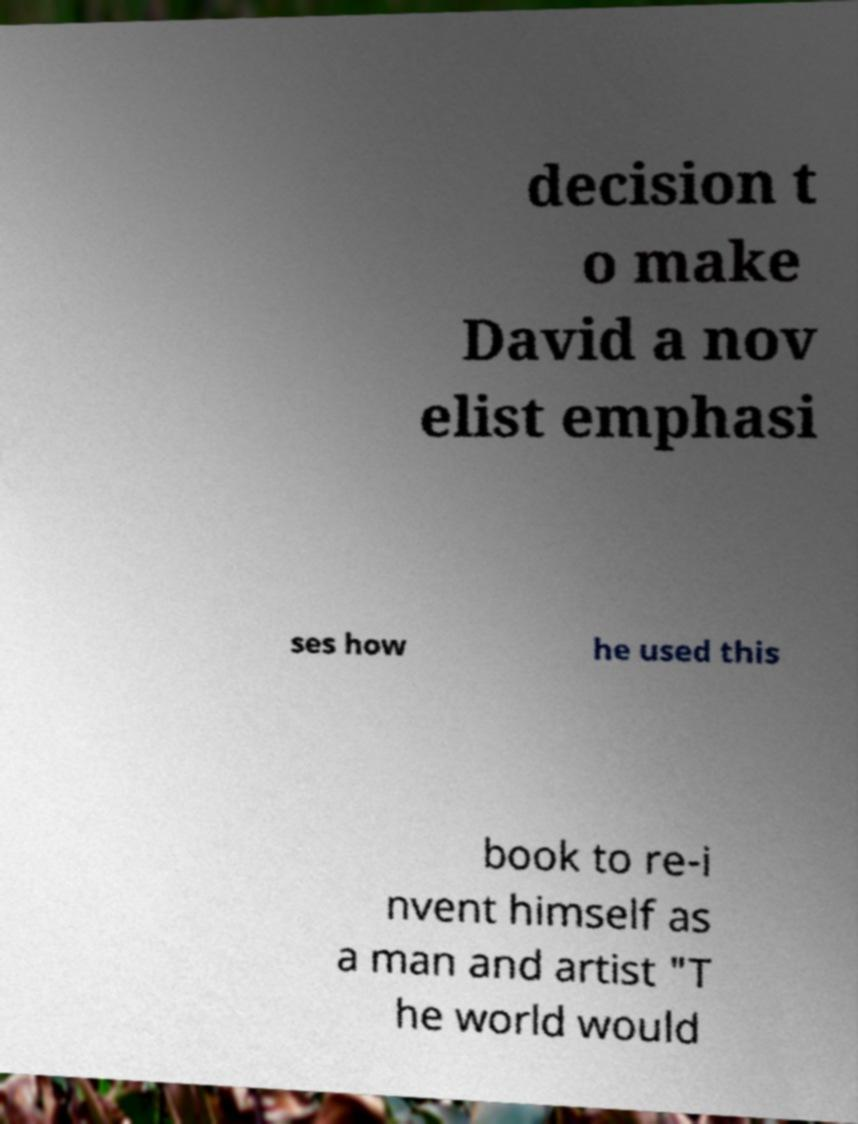Could you assist in decoding the text presented in this image and type it out clearly? decision t o make David a nov elist emphasi ses how he used this book to re-i nvent himself as a man and artist "T he world would 